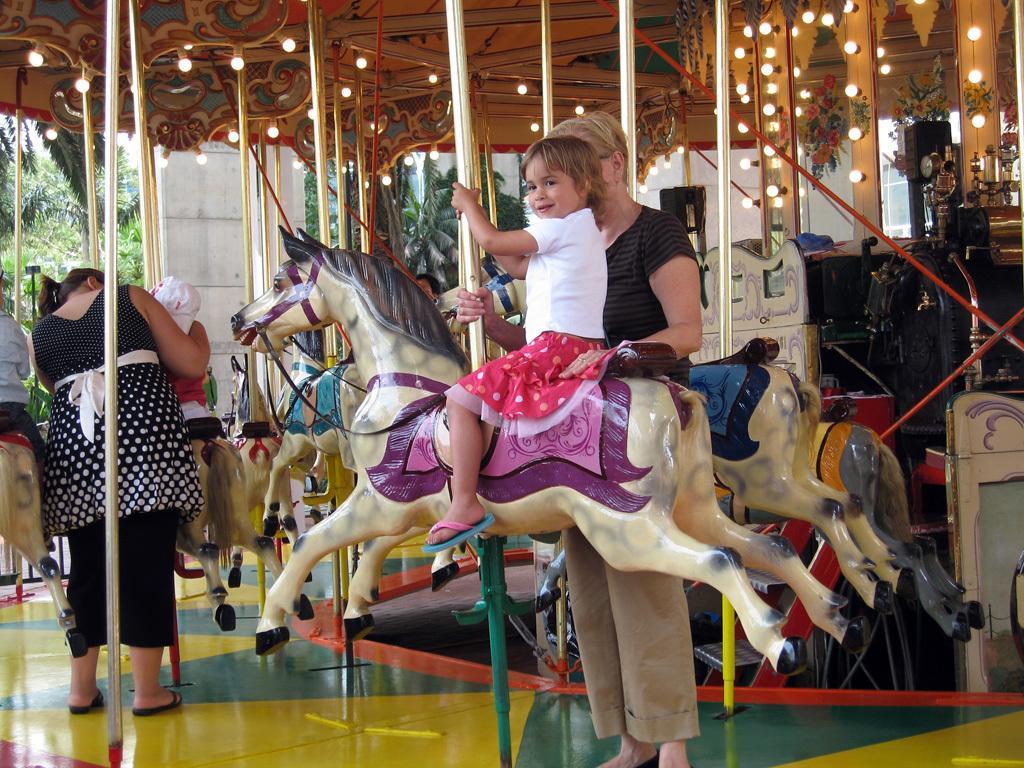Please provide a concise description of this image. In this image there are few people. In the middle of the image a girl is sitting on a toy horse and a woman is standing on the floor. At the top of the image there is a roof. In the left side of the image a woman is standing on the floor and a kid is sitting on a toy horse and there were few trees at the background. 